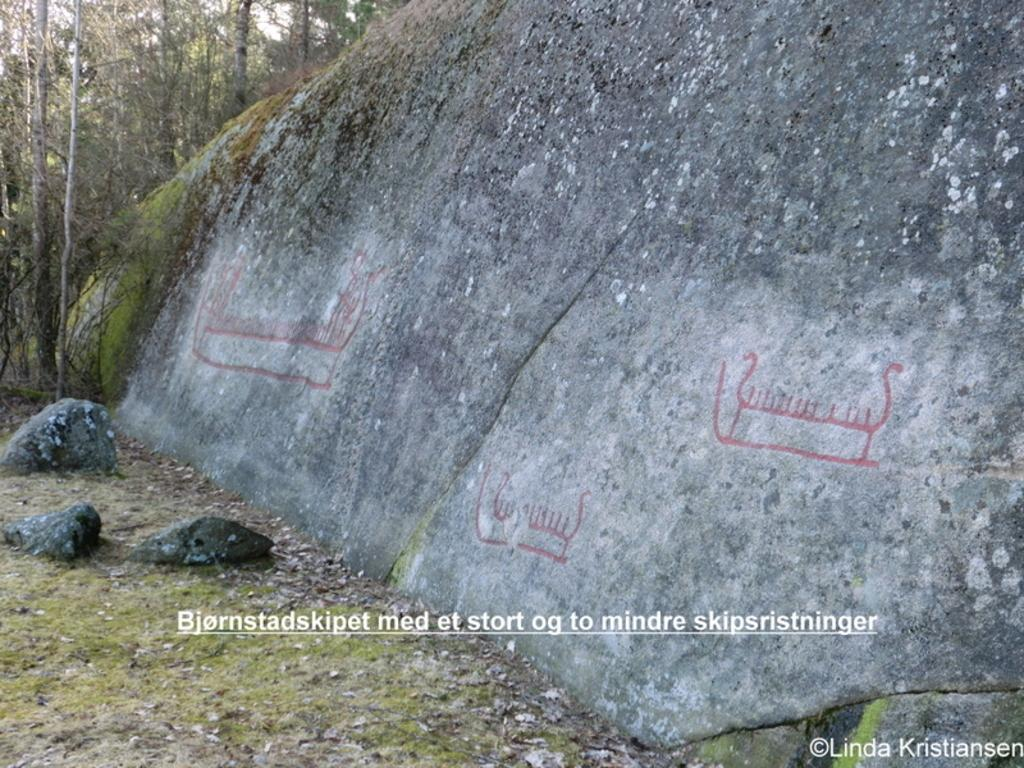What type of natural feature is truncated towards the right of the image? There is a rock truncated towards the right of the image. What type of vegetation is truncated towards the left of the image? There are trees truncated towards the left of the image. What type of ground cover can be seen in the image? There is grass visible in the image. What is present on the image besides the natural features? There is text on the image. Can you describe the farmer's interaction with the railway in the image? There is no farmer or railway present in the image. What type of stranger is depicted in the image? There is no stranger depicted in the image. 